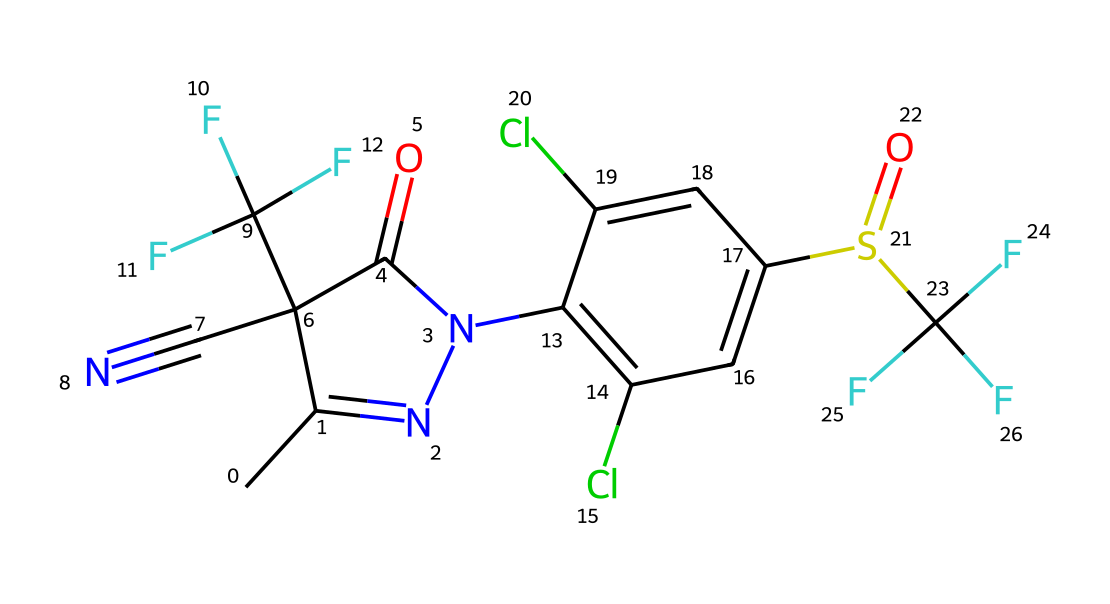What is the molecular formula of fipronil? The molecular formula can be derived by counting the number of each type of atom present in the SMILES representation. In the provided SMILES, there are 12 carbon (C), 9 hydrogen (H), 4 fluorine (F), 2 nitrogen (N), 1 oxygen (O), 2 chlorine (Cl), and 1 sulfur (S) atom. Combining these, we get C12H10Cl2F6N4O2S.
Answer: C12H10Cl2F6N4O2S How many rings are present in the structure? By analyzing the SMILES representation, it can be seen that there are two distinct cyclic components, indicated by the presence of 'C1' and 'c2', suggesting that there are two rings in total.
Answer: 2 What type of chemical structure does fipronil belong to? The structure comprises various elements that indicate it belongs to the class of insecticides, specifically a phenylpyrazole derivative as implied by its functional groups and overall composition.
Answer: phenylpyrazole What functional groups are present in fipronil? The structure of fipronil contains multiple functional groups including a sulfonyl group (due to the sulfur atom bonded to oxygen), and a carboxamide group (due to the presence of C(=O)N), as well as trifluoromethyl groups represented by C(F)(F)F.
Answer: sulfonyl, carboxamide, trifluoromethyl What is the maximum number of chlorine atoms in fipronil? Upon inspecting the provided SMILES, it shows that there are exactly two chlorine (Cl) atoms in fipronil as indicated near the aromatic region labeled as 'c'.
Answer: 2 How many nitrogen atoms are in fipronil? Counting the nitrogen atoms present in the given SMILES indicates there are two nitrogen atoms, which are indicated within the cyclic structure identified in the chemical formula.
Answer: 2 